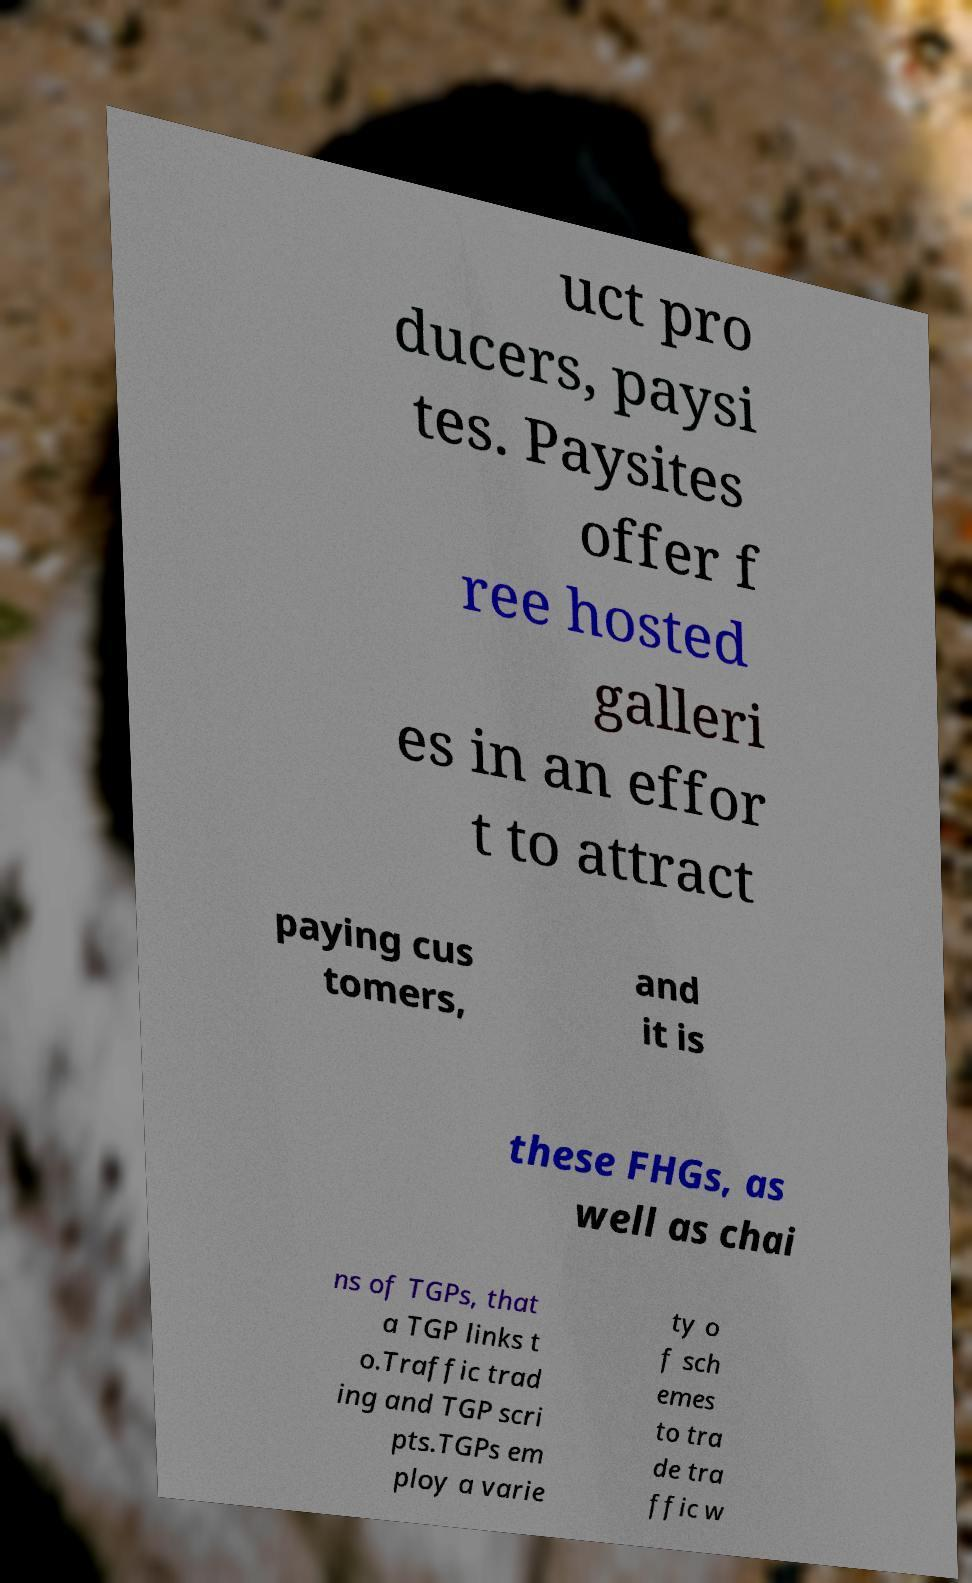There's text embedded in this image that I need extracted. Can you transcribe it verbatim? uct pro ducers, paysi tes. Paysites offer f ree hosted galleri es in an effor t to attract paying cus tomers, and it is these FHGs, as well as chai ns of TGPs, that a TGP links t o.Traffic trad ing and TGP scri pts.TGPs em ploy a varie ty o f sch emes to tra de tra ffic w 